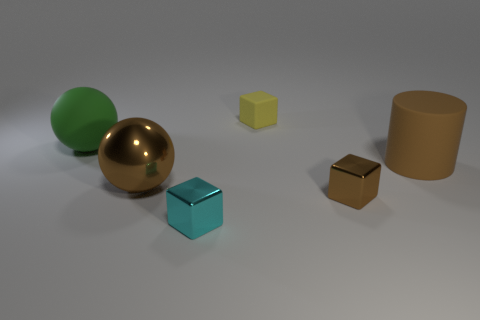There is a rubber thing that is behind the large matte ball; how many big green rubber spheres are right of it?
Your response must be concise. 0. There is a shiny sphere; is its size the same as the metallic block on the right side of the cyan block?
Give a very brief answer. No. Is the matte sphere the same size as the cyan shiny cube?
Provide a short and direct response. No. Is there another rubber object of the same size as the cyan thing?
Your answer should be compact. Yes. There is a block that is on the right side of the yellow thing; what is its material?
Make the answer very short. Metal. The sphere that is the same material as the tiny cyan cube is what color?
Your answer should be very brief. Brown. What number of matte objects are either large objects or brown spheres?
Keep it short and to the point. 2. What is the shape of the cyan thing that is the same size as the yellow object?
Give a very brief answer. Cube. How many objects are objects in front of the brown metallic sphere or objects right of the big metal thing?
Provide a succinct answer. 4. There is a brown thing that is the same size as the cyan metallic thing; what is it made of?
Your answer should be compact. Metal. 